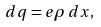<formula> <loc_0><loc_0><loc_500><loc_500>d q = e \rho \, d x ,</formula> 